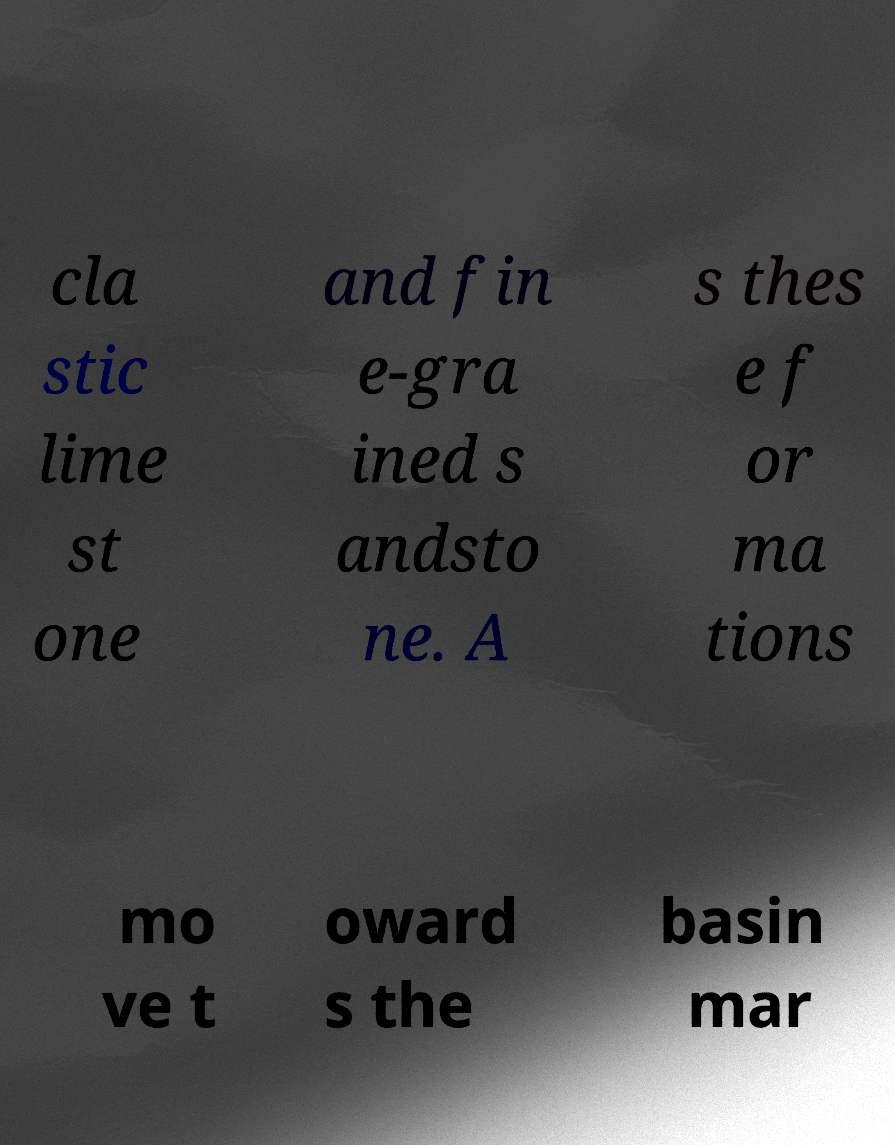What messages or text are displayed in this image? I need them in a readable, typed format. cla stic lime st one and fin e-gra ined s andsto ne. A s thes e f or ma tions mo ve t oward s the basin mar 